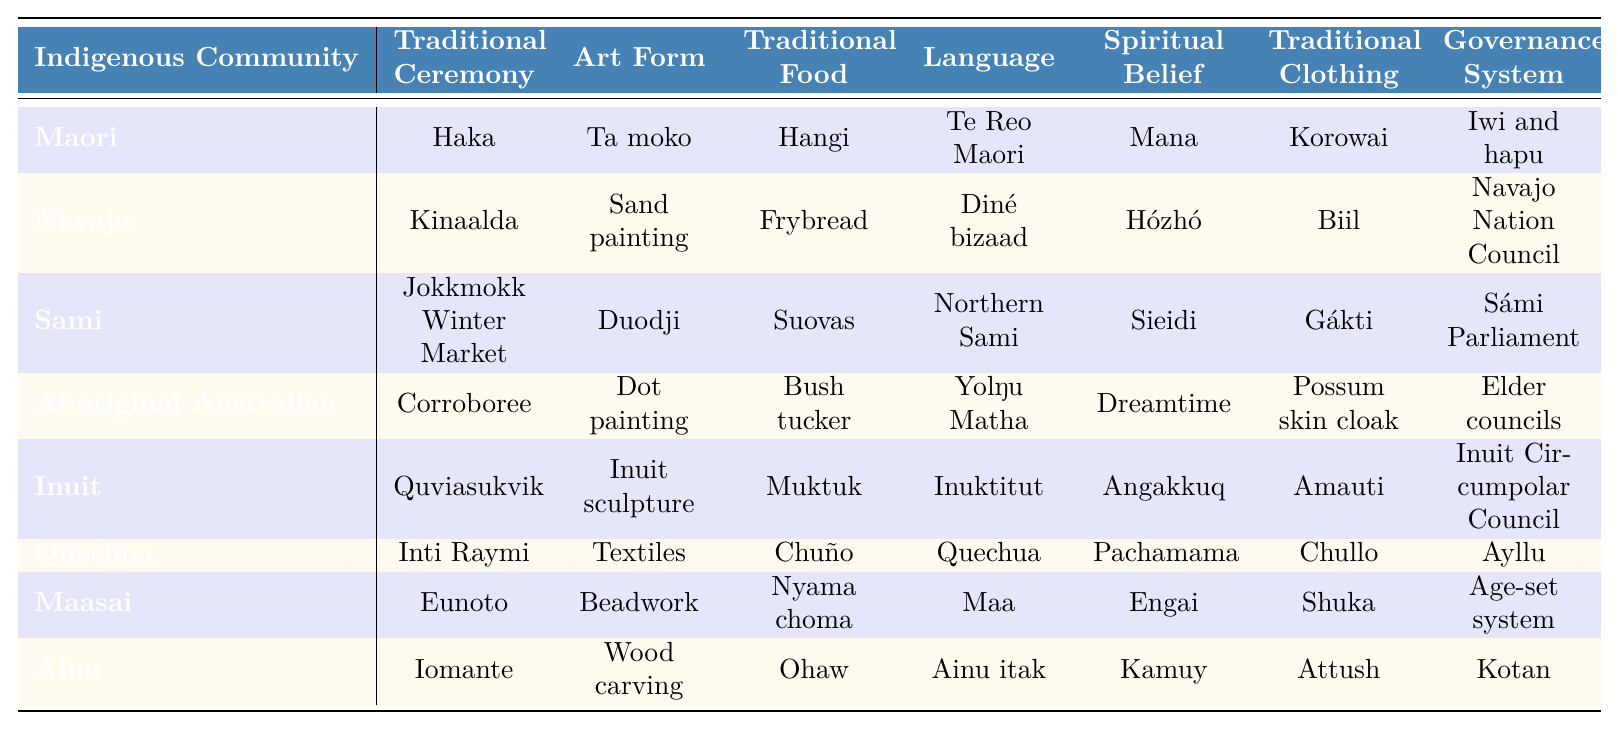What is the traditional clothing of the Inuit community? The table lists 'Amauti' as the traditional clothing associated with the Inuit community.
Answer: Amauti Which Indigenous community has 'Eunoto' as a traditional ceremony? 'Eunoto' is indicated as the traditional ceremony for the Maasai community in the table.
Answer: Maasai How many Indigenous communities have a traditional food that includes fried bread? The table shows that 'Frybread' is the traditional food for only the Navajo community. Thus, there is one community with this food.
Answer: 1 What spiritual belief is associated with the Quechua community? The table lists 'Pachamama' as the spiritual belief for the Quechua community.
Answer: Pachamama Is 'Sand painting' an art form for the Aboriginal Australian community? The table shows that 'Sand painting' is not associated with the Aboriginal Australian community; it is linked to the Navajo community instead.
Answer: No Which Indigenous community uses 'Inti Raymi' as a traditional ceremony and what is its associated art form? Looking at the table, 'Inti Raymi' is the traditional ceremony for the Quechua community, which is associated with the art form 'Textiles.'
Answer: Quechua; Textiles What are the two languages used by the Indigenous communities with traditional foods 'Bush tucker' and 'Muktuk'? The table links 'Bush tucker' to the Aboriginal Australian community (using Yolŋu Matha) and 'Muktuk' to the Inuit community (using Inuktitut).
Answer: Yolŋu Matha; Inuktitut How many Indigenous communities have a governance system involving councils? The table indicates that the Navajo Nation Council, Elder councils, and Inuit Circumpolar Council are governance systems involving councils, which totals three communities.
Answer: 3 Which community has the highest variety of traditional ceremonies listed based on this table? The table indicates that the traditional ceremonies for the communities listed do not include multiple ceremonies per community, with each community only having one. Thus, no community stands out with a higher variety.
Answer: None What is the traditional ceremony and food for the Sami community? According to the table, the Sami community has 'Jokkmokk Winter Market' as its traditional ceremony and 'Suovas' as its traditional food.
Answer: Jokkmokk Winter Market; Suovas 